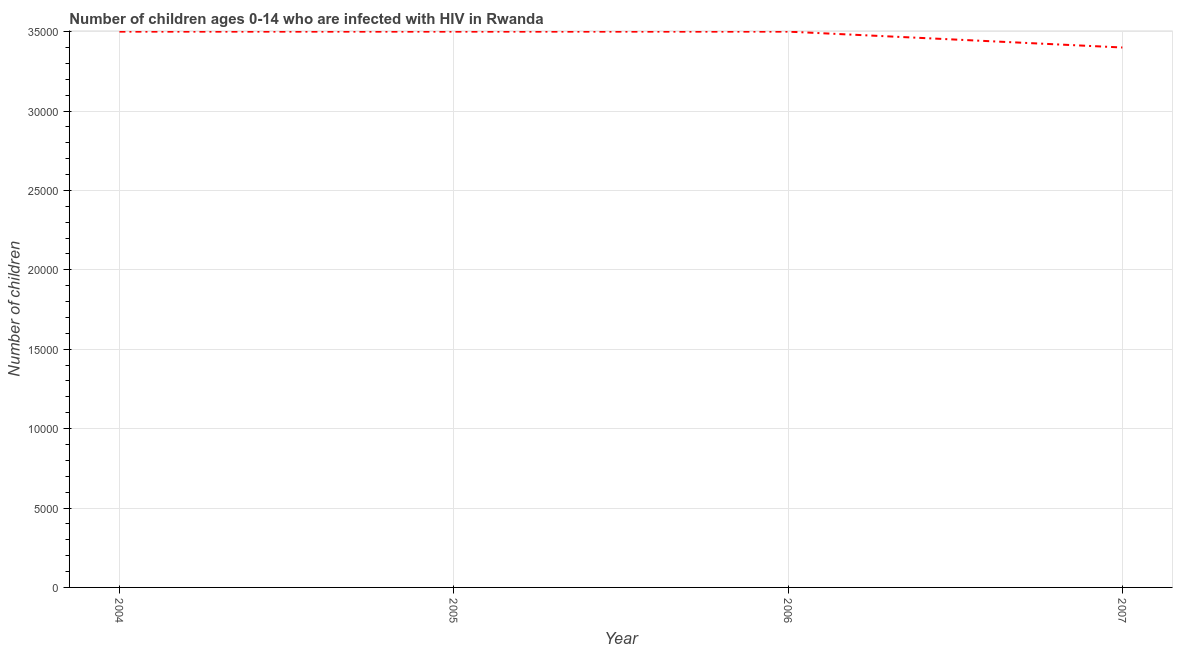What is the number of children living with hiv in 2004?
Your response must be concise. 3.50e+04. Across all years, what is the maximum number of children living with hiv?
Keep it short and to the point. 3.50e+04. Across all years, what is the minimum number of children living with hiv?
Offer a very short reply. 3.40e+04. What is the sum of the number of children living with hiv?
Offer a terse response. 1.39e+05. What is the average number of children living with hiv per year?
Provide a succinct answer. 3.48e+04. What is the median number of children living with hiv?
Provide a short and direct response. 3.50e+04. In how many years, is the number of children living with hiv greater than 30000 ?
Your answer should be very brief. 4. What is the ratio of the number of children living with hiv in 2005 to that in 2007?
Your answer should be compact. 1.03. What is the difference between the highest and the lowest number of children living with hiv?
Your answer should be compact. 1000. Does the number of children living with hiv monotonically increase over the years?
Your answer should be very brief. No. How many lines are there?
Give a very brief answer. 1. What is the difference between two consecutive major ticks on the Y-axis?
Provide a short and direct response. 5000. Are the values on the major ticks of Y-axis written in scientific E-notation?
Provide a succinct answer. No. What is the title of the graph?
Your answer should be very brief. Number of children ages 0-14 who are infected with HIV in Rwanda. What is the label or title of the Y-axis?
Your response must be concise. Number of children. What is the Number of children in 2004?
Keep it short and to the point. 3.50e+04. What is the Number of children in 2005?
Keep it short and to the point. 3.50e+04. What is the Number of children of 2006?
Your response must be concise. 3.50e+04. What is the Number of children of 2007?
Your response must be concise. 3.40e+04. What is the difference between the Number of children in 2004 and 2006?
Offer a terse response. 0. What is the difference between the Number of children in 2004 and 2007?
Your answer should be very brief. 1000. What is the difference between the Number of children in 2005 and 2006?
Give a very brief answer. 0. What is the difference between the Number of children in 2005 and 2007?
Ensure brevity in your answer.  1000. What is the ratio of the Number of children in 2004 to that in 2006?
Ensure brevity in your answer.  1. What is the ratio of the Number of children in 2005 to that in 2006?
Offer a very short reply. 1. What is the ratio of the Number of children in 2006 to that in 2007?
Your answer should be very brief. 1.03. 